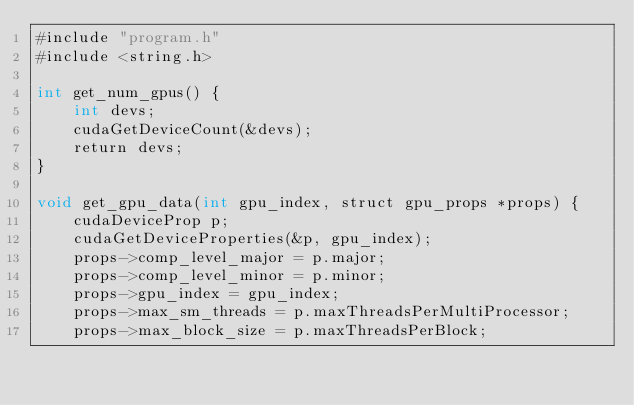<code> <loc_0><loc_0><loc_500><loc_500><_Cuda_>#include "program.h"
#include <string.h>

int get_num_gpus() {
    int devs;
    cudaGetDeviceCount(&devs);
    return devs;
}

void get_gpu_data(int gpu_index, struct gpu_props *props) {
    cudaDeviceProp p;
    cudaGetDeviceProperties(&p, gpu_index);
    props->comp_level_major = p.major;
    props->comp_level_minor = p.minor;
    props->gpu_index = gpu_index;
    props->max_sm_threads = p.maxThreadsPerMultiProcessor;
    props->max_block_size = p.maxThreadsPerBlock;</code> 